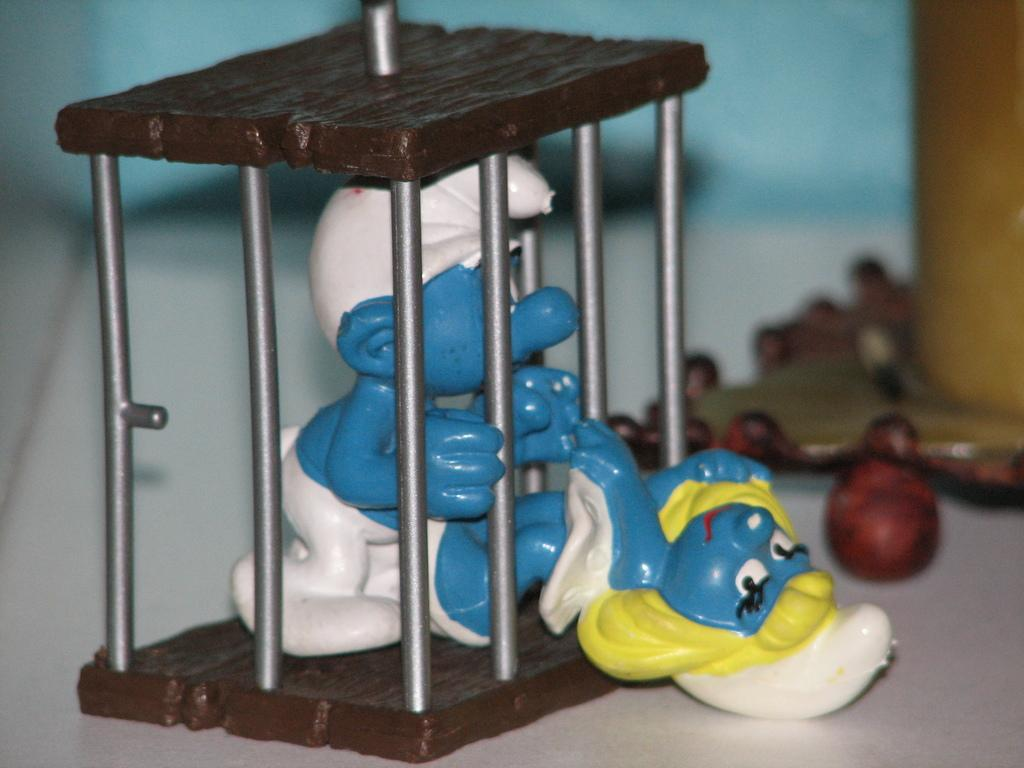What is the main object in the center of the image? There is a table in the center of the image. What is on top of the table? There is a toy cage and other toys on the table. Can you describe the toy cage? The toy cage is present on the table. Are there any other toys visible in the image? Yes, there are other toys on the table. What type of zebra can be seen in the toy cage in the image? There is no zebra present in the image. What type of coach is visible in the image? There is no coach present in the image. 